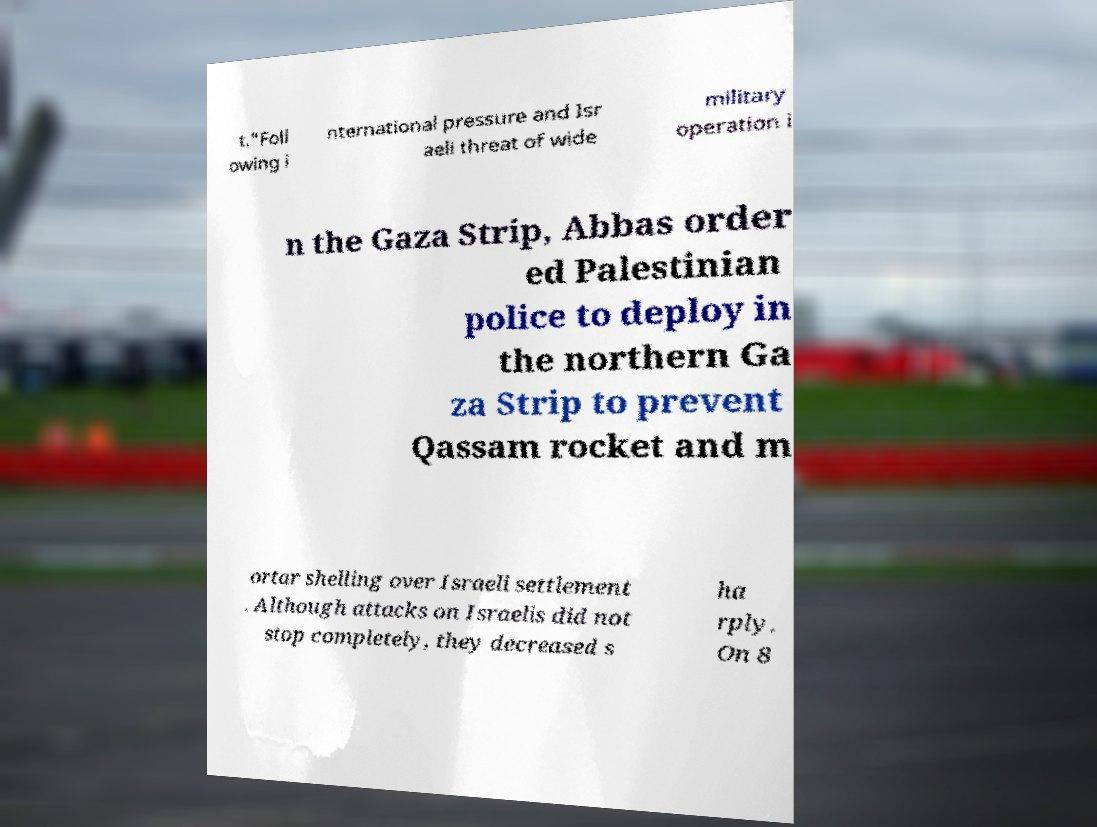There's text embedded in this image that I need extracted. Can you transcribe it verbatim? t."Foll owing i nternational pressure and Isr aeli threat of wide military operation i n the Gaza Strip, Abbas order ed Palestinian police to deploy in the northern Ga za Strip to prevent Qassam rocket and m ortar shelling over Israeli settlement . Although attacks on Israelis did not stop completely, they decreased s ha rply. On 8 